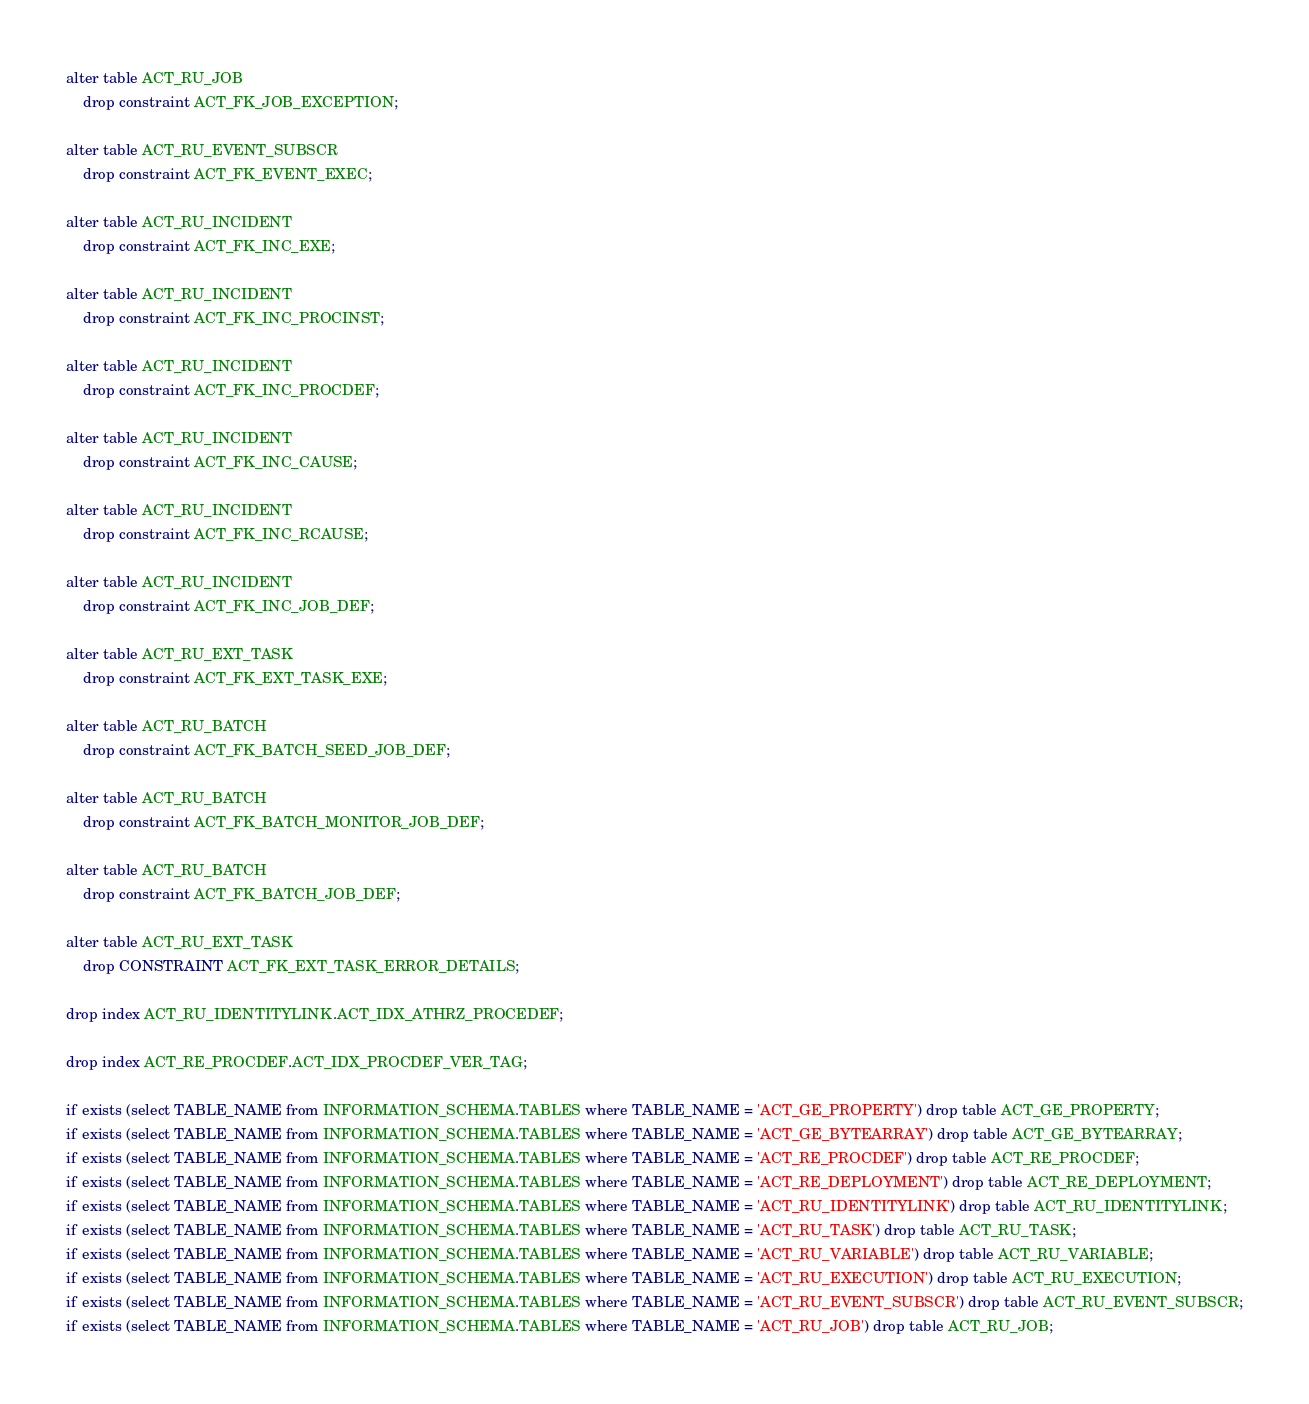<code> <loc_0><loc_0><loc_500><loc_500><_SQL_>alter table ACT_RU_JOB
    drop constraint ACT_FK_JOB_EXCEPTION;

alter table ACT_RU_EVENT_SUBSCR
    drop constraint ACT_FK_EVENT_EXEC;

alter table ACT_RU_INCIDENT
    drop constraint ACT_FK_INC_EXE;

alter table ACT_RU_INCIDENT
    drop constraint ACT_FK_INC_PROCINST;

alter table ACT_RU_INCIDENT
    drop constraint ACT_FK_INC_PROCDEF;

alter table ACT_RU_INCIDENT
    drop constraint ACT_FK_INC_CAUSE;

alter table ACT_RU_INCIDENT
    drop constraint ACT_FK_INC_RCAUSE;

alter table ACT_RU_INCIDENT
    drop constraint ACT_FK_INC_JOB_DEF;

alter table ACT_RU_EXT_TASK
    drop constraint ACT_FK_EXT_TASK_EXE;

alter table ACT_RU_BATCH
    drop constraint ACT_FK_BATCH_SEED_JOB_DEF;

alter table ACT_RU_BATCH
    drop constraint ACT_FK_BATCH_MONITOR_JOB_DEF;

alter table ACT_RU_BATCH
    drop constraint ACT_FK_BATCH_JOB_DEF;

alter table ACT_RU_EXT_TASK
    drop CONSTRAINT ACT_FK_EXT_TASK_ERROR_DETAILS;

drop index ACT_RU_IDENTITYLINK.ACT_IDX_ATHRZ_PROCEDEF;

drop index ACT_RE_PROCDEF.ACT_IDX_PROCDEF_VER_TAG;

if exists (select TABLE_NAME from INFORMATION_SCHEMA.TABLES where TABLE_NAME = 'ACT_GE_PROPERTY') drop table ACT_GE_PROPERTY;
if exists (select TABLE_NAME from INFORMATION_SCHEMA.TABLES where TABLE_NAME = 'ACT_GE_BYTEARRAY') drop table ACT_GE_BYTEARRAY;
if exists (select TABLE_NAME from INFORMATION_SCHEMA.TABLES where TABLE_NAME = 'ACT_RE_PROCDEF') drop table ACT_RE_PROCDEF;
if exists (select TABLE_NAME from INFORMATION_SCHEMA.TABLES where TABLE_NAME = 'ACT_RE_DEPLOYMENT') drop table ACT_RE_DEPLOYMENT;
if exists (select TABLE_NAME from INFORMATION_SCHEMA.TABLES where TABLE_NAME = 'ACT_RU_IDENTITYLINK') drop table ACT_RU_IDENTITYLINK;
if exists (select TABLE_NAME from INFORMATION_SCHEMA.TABLES where TABLE_NAME = 'ACT_RU_TASK') drop table ACT_RU_TASK;
if exists (select TABLE_NAME from INFORMATION_SCHEMA.TABLES where TABLE_NAME = 'ACT_RU_VARIABLE') drop table ACT_RU_VARIABLE;
if exists (select TABLE_NAME from INFORMATION_SCHEMA.TABLES where TABLE_NAME = 'ACT_RU_EXECUTION') drop table ACT_RU_EXECUTION;
if exists (select TABLE_NAME from INFORMATION_SCHEMA.TABLES where TABLE_NAME = 'ACT_RU_EVENT_SUBSCR') drop table ACT_RU_EVENT_SUBSCR;
if exists (select TABLE_NAME from INFORMATION_SCHEMA.TABLES where TABLE_NAME = 'ACT_RU_JOB') drop table ACT_RU_JOB;</code> 